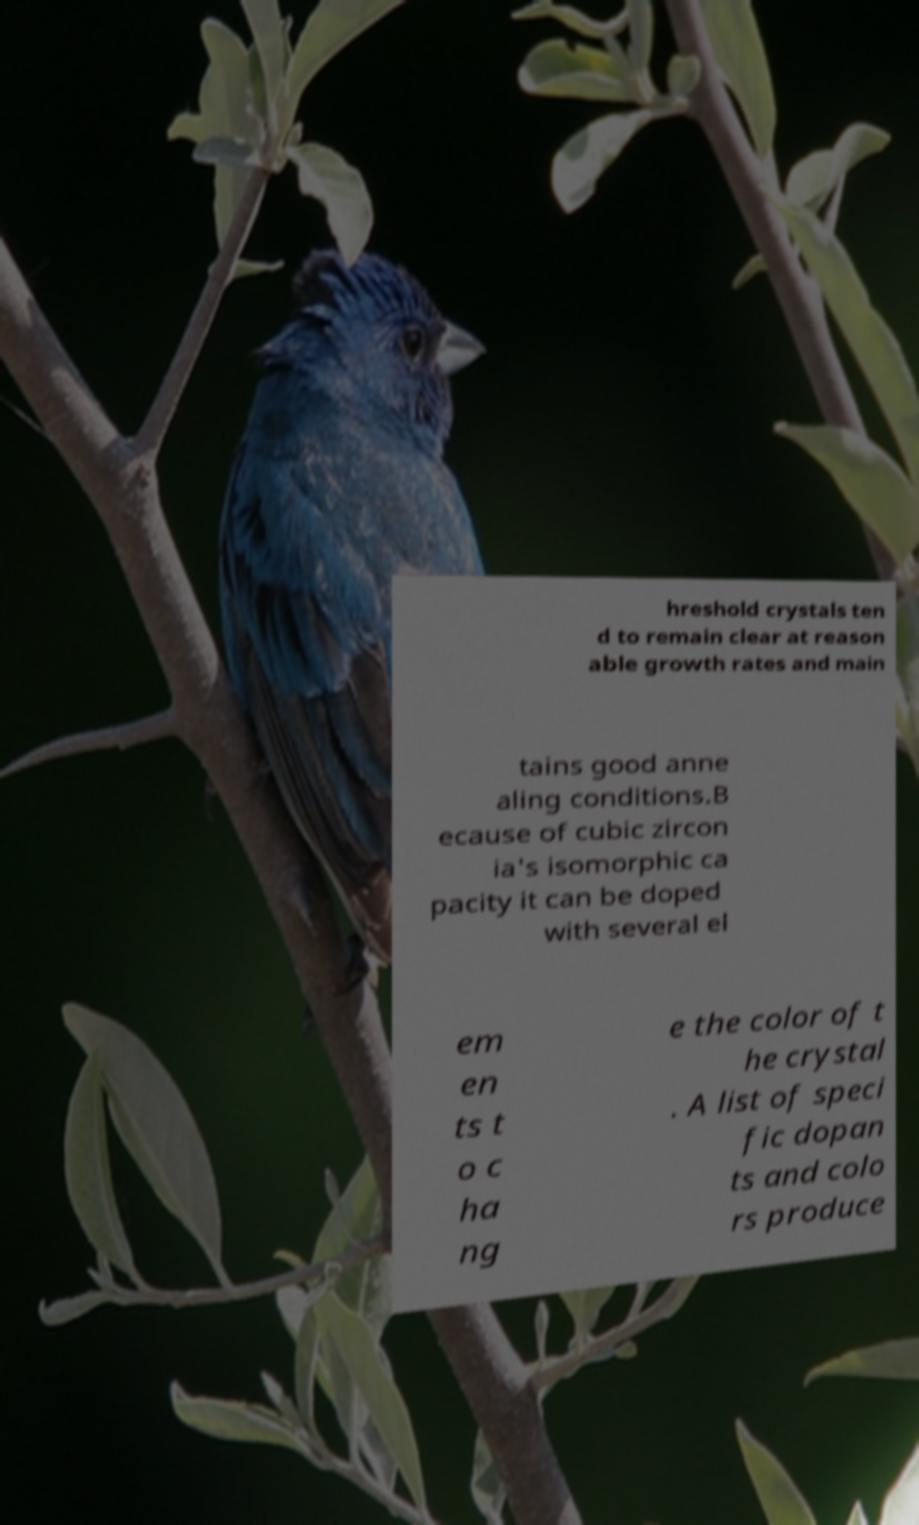There's text embedded in this image that I need extracted. Can you transcribe it verbatim? hreshold crystals ten d to remain clear at reason able growth rates and main tains good anne aling conditions.B ecause of cubic zircon ia's isomorphic ca pacity it can be doped with several el em en ts t o c ha ng e the color of t he crystal . A list of speci fic dopan ts and colo rs produce 